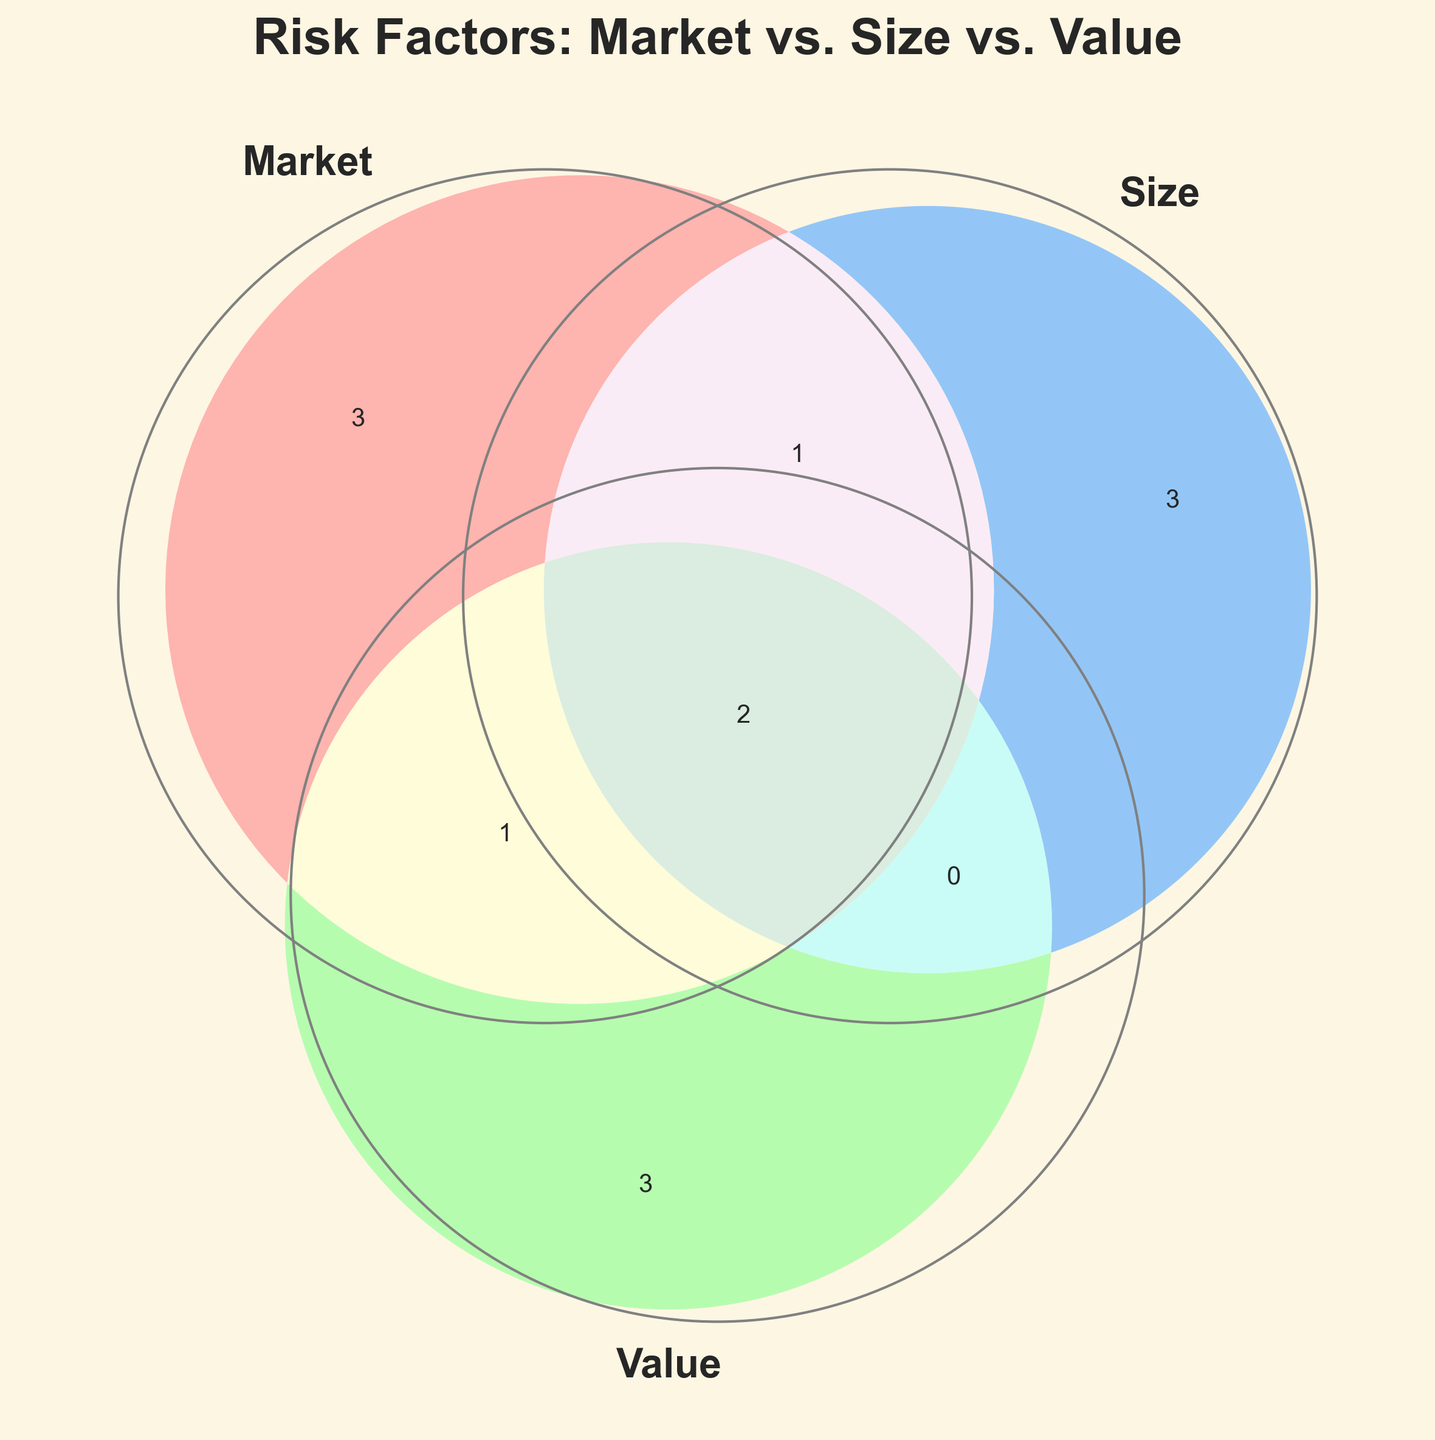What is the title of the Venn Diagram? The title is given at the top of the Venn Diagram. It can be read directly.
Answer: Risk Factors: Market vs. Size vs. Value Which color represents the 'Value' risk factor? The colors for each risk factor can be identified by looking at the corresponding circles in the Venn Diagram. 'Value' is the green circle.
Answer: Green How many risk factors are common to all three risk types: Market, Size, and Value? By looking at the intersection area that is shared by all three circles, we can count the number of risk factors listed inside this area.
Answer: Two What risk factors are specific to the 'Size' risk but not shared with others? The factors specific to 'Size' are in the 'Size' circle but not in any intersection with 'Market' or 'Value'.
Answer: Market cap, Small-cap premium, Liquidity Which risk factors overlap between 'Market' and 'Size'? The intersection area between the 'Market' and 'Size' circles shows the common risk factors.
Answer: Momentum, Sector exposure, Economic cycles Which areas in the Venn Diagram have the least number of risk factors? By comparing all the distinct and overlapping areas, we find that the areas with fewer labels have the least number of risk factors.
Answer: The areas for 'Market', 'Size' only, and 'Value' only How many risk factors does the 'Market' risk type encompass, considering all overlaps? By counting the number of risk factors within the 'Market' circle, including all its intersections, we determine this total.
Answer: Nine Identify the risk factors that 'Value' shares with 'Size' but not with 'Market'. This information is in the intersection area between the 'Value' and 'Size' circles, excluding their overlap with 'Market'.
Answer: None Which risk type contains 'Beta'? By locating 'Beta' in the diagram, we see it falls into the 'Market' risk circle.
Answer: Market What common economic factors are shared by 'Market', 'Size', and 'Value'? The area where all three circles intersect contains the factors common to all three.
Answer: Sector exposure, Economic cycles 